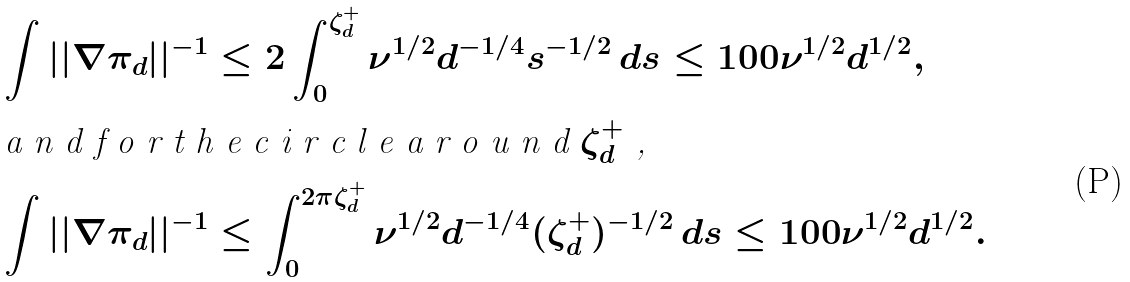Convert formula to latex. <formula><loc_0><loc_0><loc_500><loc_500>\int | | \nabla \pi _ { d } | | ^ { - 1 } & \leq 2 \int _ { 0 } ^ { \zeta _ { d } ^ { + } } \nu ^ { 1 / 2 } d ^ { - 1 / 4 } s ^ { - 1 / 2 } \, d s \leq 1 0 0 \nu ^ { 1 / 2 } d ^ { 1 / 2 } , \\ \intertext { a n d f o r t h e c i r c l e a r o u n d $ \zeta _ { d } ^ { + } $ , } \int | | \nabla \pi _ { d } | | ^ { - 1 } & \leq \int _ { 0 } ^ { 2 \pi \zeta _ { d } ^ { + } } \nu ^ { 1 / 2 } d ^ { - 1 / 4 } ( \zeta _ { d } ^ { + } ) ^ { - 1 / 2 } \, d s \leq 1 0 0 \nu ^ { 1 / 2 } d ^ { 1 / 2 } .</formula> 